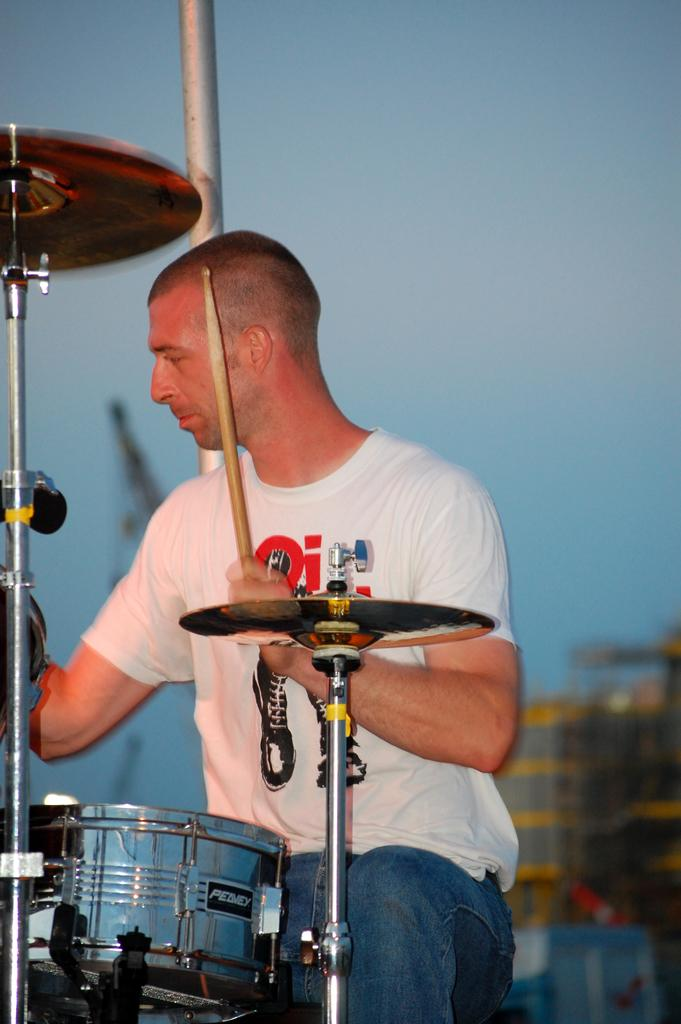What is the man in the image doing? The man is sitting in the image. What is the man holding in the image? The man is holding a stick in the image. What object related to music can be seen in the image? There is a musical instrument in the image. What vertical structure is present in the image? There is a pole in the image. How would you describe the background of the image? The background of the image is blurry. Where is the pocket located in the image? There is no pocket mentioned or visible in the image. What type of fuel is being used by the man in the image? There is no indication of any fuel being used in the image. 